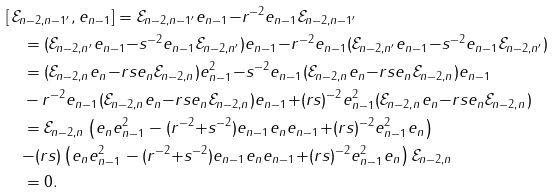<formula> <loc_0><loc_0><loc_500><loc_500>& [ \, \mathcal { E } _ { n - 2 , n - 1 ^ { \prime } } , e _ { n - 1 } ] = \mathcal { E } _ { n - 2 , n - 1 ^ { \prime } } e _ { n - 1 } { - } r ^ { - 2 } e _ { n - 1 } \mathcal { E } _ { n - 2 , n - 1 ^ { \prime } } \\ & \quad = ( \mathcal { E } _ { n - 2 , n ^ { \prime } } e _ { n - 1 } { - } s ^ { - 2 } e _ { n - 1 } \mathcal { E } _ { n - 2 , n ^ { \prime } } ) e _ { n - 1 } { - } r ^ { - 2 } e _ { n - 1 } ( \mathcal { E } _ { n - 2 , n ^ { \prime } } e _ { n - 1 } { - } s ^ { - 2 } e _ { n - 1 } \mathcal { E } _ { n - 2 , n ^ { \prime } } ) \\ & \quad = ( \mathcal { E } _ { n - 2 , n } e _ { n } { - } r s e _ { n } \mathcal { E } _ { n - 2 , n } ) e _ { n - 1 } ^ { 2 } { - } s ^ { - 2 } e _ { n - 1 } ( \mathcal { E } _ { n - 2 , n } e _ { n } { - } r s e _ { n } \mathcal { E } _ { n - 2 , n } ) e _ { n - 1 } \\ & \quad - r ^ { - 2 } e _ { n - 1 } ( \mathcal { E } _ { n - 2 , n } e _ { n } { - } r s e _ { n } \mathcal { E } _ { n - 2 , n } ) e _ { n - 1 } { + } ( r s ) ^ { - 2 } e _ { n - 1 } ^ { 2 } ( \mathcal { E } _ { n - 2 , n } e _ { n } { - } r s e _ { n } \mathcal { E } _ { n - 2 , n } ) \\ & \quad = \mathcal { E } _ { n - 2 , n } \left ( e _ { n } e _ { n - 1 } ^ { 2 } - ( r ^ { - 2 } { + } s ^ { - 2 } ) e _ { n - 1 } e _ { n } e _ { n - 1 } { + } ( r s ) ^ { - 2 } e _ { n - 1 } ^ { 2 } e _ { n } \right ) \\ & \quad { - } ( r s ) \left ( e _ { n } e _ { n - 1 } ^ { 2 } - ( r ^ { - 2 } { + } s ^ { - 2 } ) e _ { n - 1 } e _ { n } e _ { n - 1 } { + } ( r s ) ^ { - 2 } e _ { n - 1 } ^ { 2 } e _ { n } \right ) \mathcal { E } _ { n - 2 , n } \\ & \quad = 0 .</formula> 